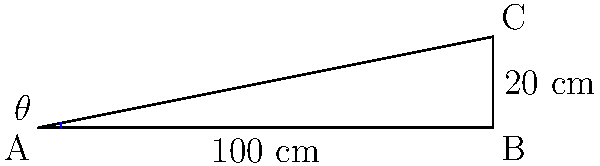In designing an efficient bottling line conveyor belt, you need to determine the optimal angle of inclination. Given a horizontal distance of 100 cm and a vertical rise of 20 cm, what is the angle of inclination $\theta$ in degrees, rounded to the nearest tenth? To find the angle of inclination $\theta$, we can use the trigonometric function tangent. Here's how:

1) In a right triangle, $\tan(\theta) = \frac{\text{opposite}}{\text{adjacent}}$

2) In this case:
   - The opposite side (vertical rise) is 20 cm
   - The adjacent side (horizontal distance) is 100 cm

3) Therefore:
   $\tan(\theta) = \frac{20}{100} = 0.2$

4) To find $\theta$, we need to use the inverse tangent (arctan or $\tan^{-1}$):
   $\theta = \tan^{-1}(0.2)$

5) Using a calculator or computer:
   $\theta \approx 11.3099325$ degrees

6) Rounding to the nearest tenth:
   $\theta \approx 11.3$ degrees

This angle provides an efficient incline for the bottling line conveyor belt, balancing the need for vertical movement with a manageable slope for bottle stability.
Answer: $11.3^\circ$ 